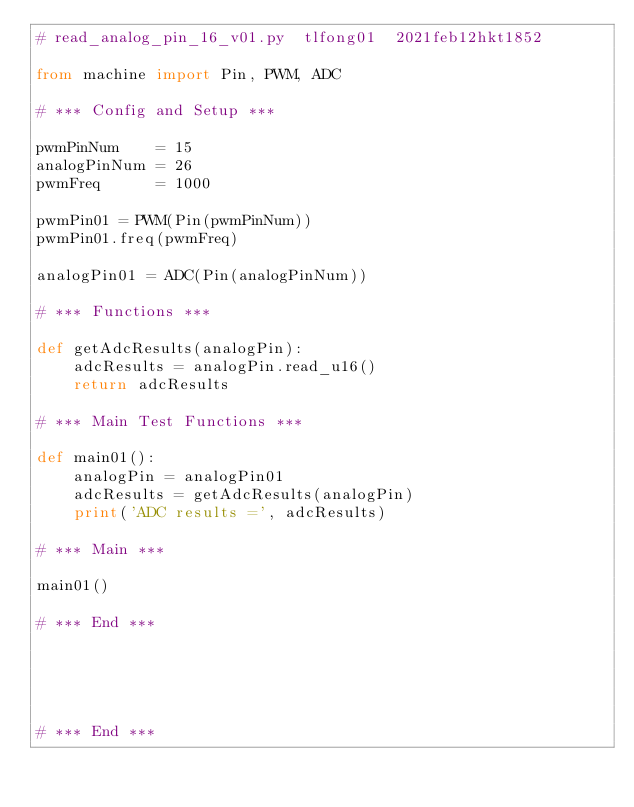Convert code to text. <code><loc_0><loc_0><loc_500><loc_500><_Python_># read_analog_pin_16_v01.py  tlfong01  2021feb12hkt1852

from machine import Pin, PWM, ADC

# *** Config and Setup ***

pwmPinNum    = 15
analogPinNum = 26
pwmFreq      = 1000

pwmPin01 = PWM(Pin(pwmPinNum))
pwmPin01.freq(pwmFreq)

analogPin01 = ADC(Pin(analogPinNum))

# *** Functions ***

def getAdcResults(analogPin):
    adcResults = analogPin.read_u16()
    return adcResults

# *** Main Test Functions ***

def main01():
    analogPin = analogPin01
    adcResults = getAdcResults(analogPin)
    print('ADC results =', adcResults)
    
# *** Main ***

main01()

# *** End ***





# *** End ***


</code> 